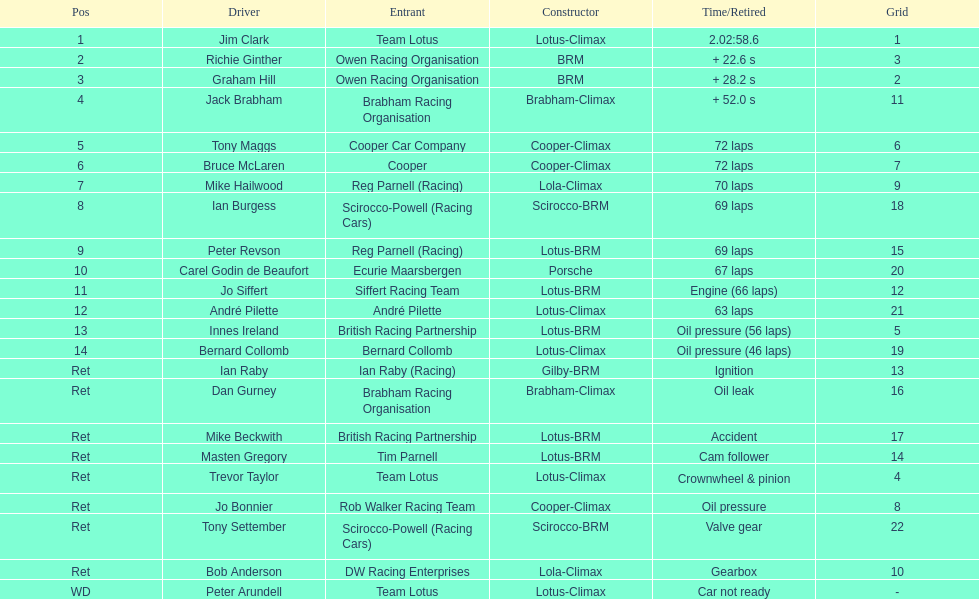How many competitors had cooper-climax as their builder? 3. 